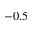<formula> <loc_0><loc_0><loc_500><loc_500>- 0 . 5</formula> 